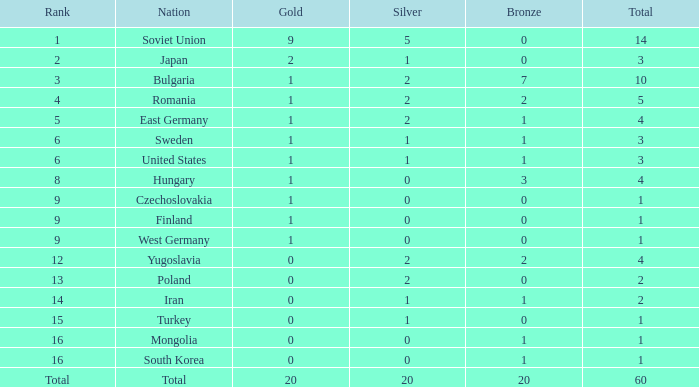I'm looking to parse the entire table for insights. Could you assist me with that? {'header': ['Rank', 'Nation', 'Gold', 'Silver', 'Bronze', 'Total'], 'rows': [['1', 'Soviet Union', '9', '5', '0', '14'], ['2', 'Japan', '2', '1', '0', '3'], ['3', 'Bulgaria', '1', '2', '7', '10'], ['4', 'Romania', '1', '2', '2', '5'], ['5', 'East Germany', '1', '2', '1', '4'], ['6', 'Sweden', '1', '1', '1', '3'], ['6', 'United States', '1', '1', '1', '3'], ['8', 'Hungary', '1', '0', '3', '4'], ['9', 'Czechoslovakia', '1', '0', '0', '1'], ['9', 'Finland', '1', '0', '0', '1'], ['9', 'West Germany', '1', '0', '0', '1'], ['12', 'Yugoslavia', '0', '2', '2', '4'], ['13', 'Poland', '0', '2', '0', '2'], ['14', 'Iran', '0', '1', '1', '2'], ['15', 'Turkey', '0', '1', '0', '1'], ['16', 'Mongolia', '0', '0', '1', '1'], ['16', 'South Korea', '0', '0', '1', '1'], ['Total', 'Total', '20', '20', '20', '60']]} What is the total number of golds for positions with a rank of 6 and a total of more than 3? None. 